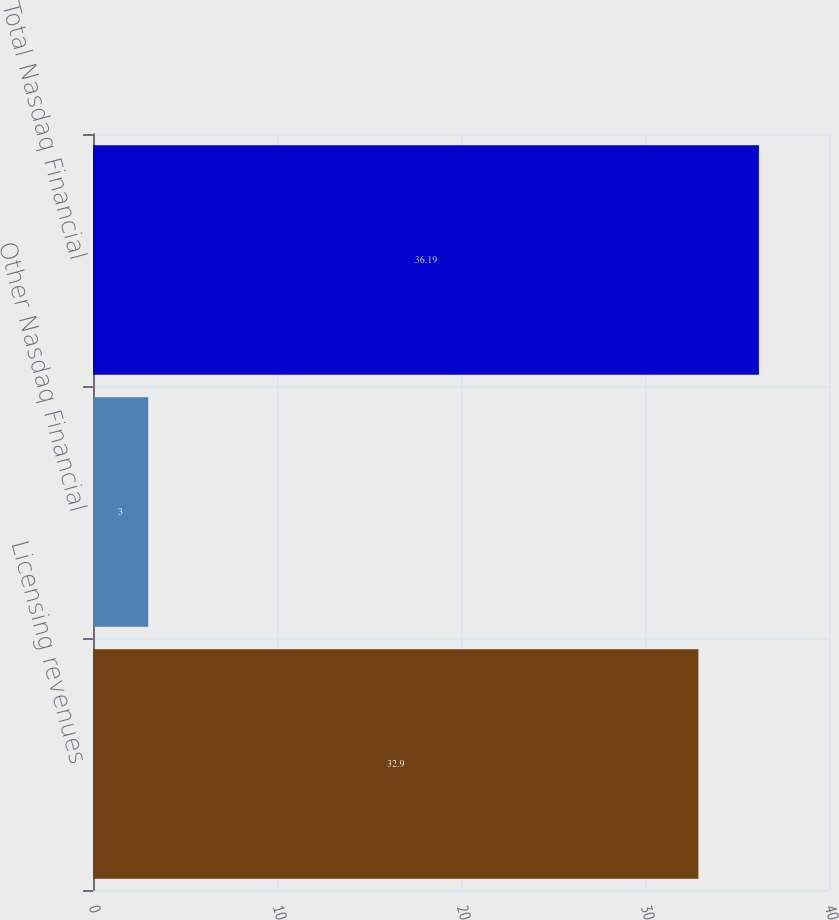Convert chart. <chart><loc_0><loc_0><loc_500><loc_500><bar_chart><fcel>Licensing revenues<fcel>Other Nasdaq Financial<fcel>Total Nasdaq Financial<nl><fcel>32.9<fcel>3<fcel>36.19<nl></chart> 